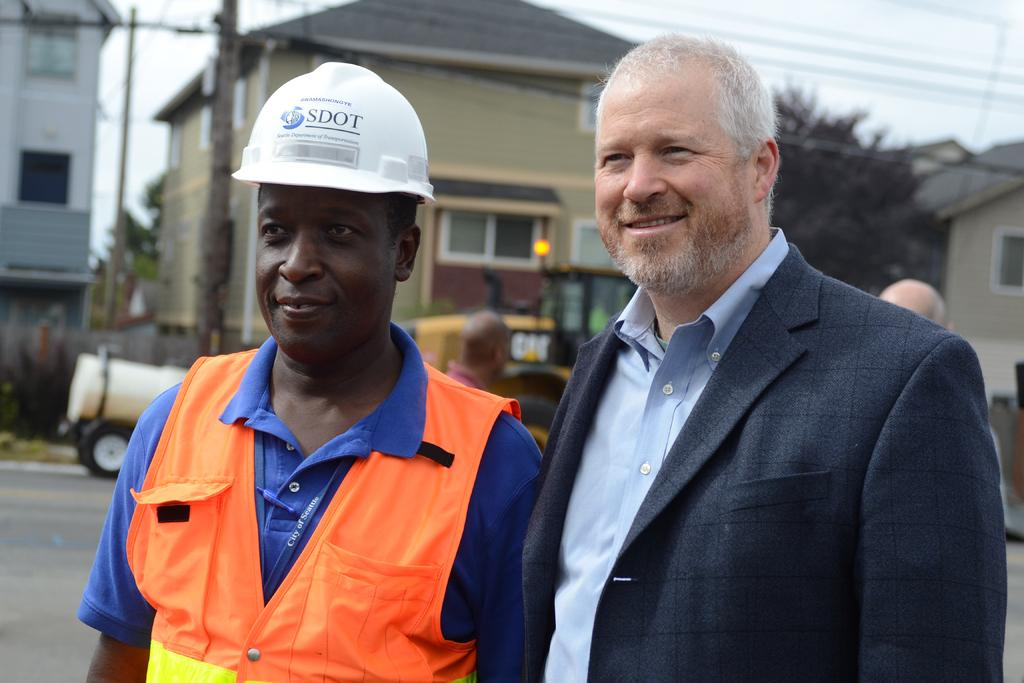What is happening in the center of the image? There are persons standing on the road in the center of the image. What can be seen in the background of the image? There are buildings, trees, poles, vehicles, and the sky visible in the background of the image. What historical event is being commemorated by the persons standing on the road in the image? There is no indication of a historical event being commemorated in the image. The persons standing on the road are not engaged in any activity that suggests a commemoration or celebration. 